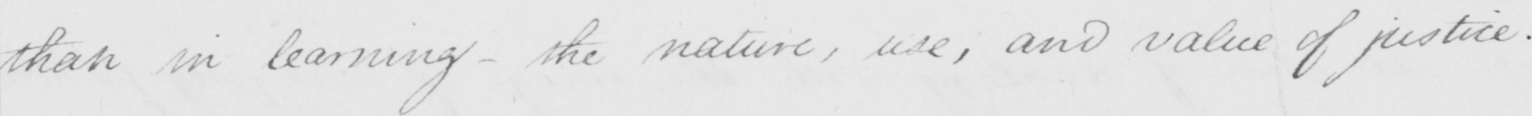What is written in this line of handwriting? than in learning  _  the nature , use , and value of justice .  _ 